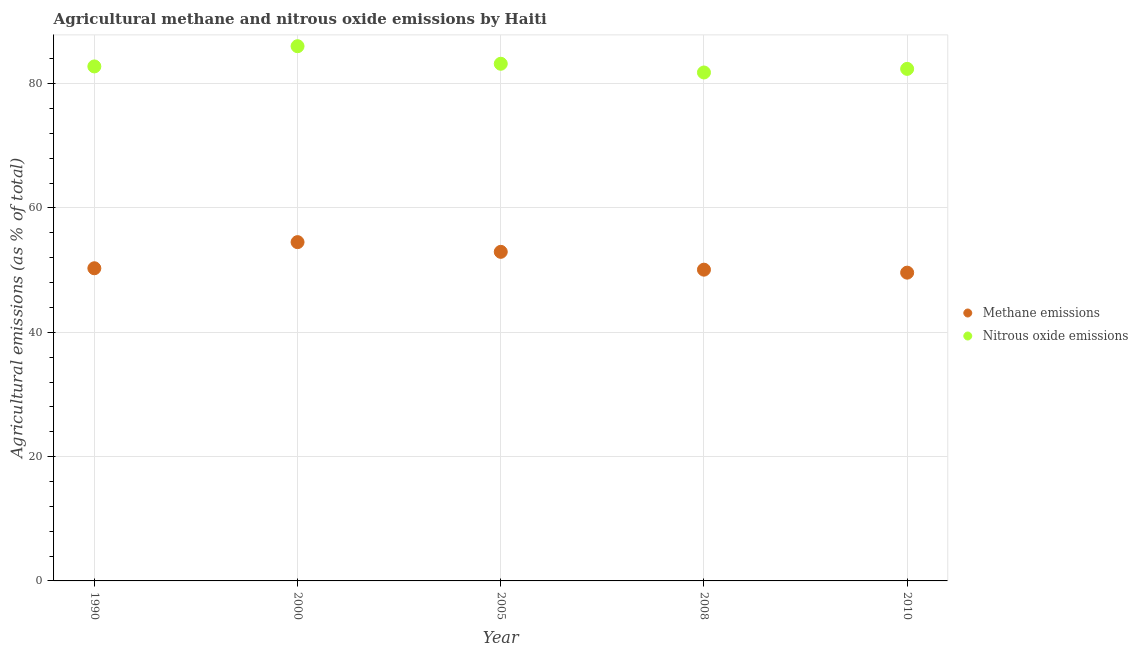How many different coloured dotlines are there?
Provide a short and direct response. 2. What is the amount of nitrous oxide emissions in 2005?
Your answer should be very brief. 83.2. Across all years, what is the maximum amount of methane emissions?
Make the answer very short. 54.51. Across all years, what is the minimum amount of methane emissions?
Ensure brevity in your answer.  49.6. What is the total amount of nitrous oxide emissions in the graph?
Keep it short and to the point. 416.19. What is the difference between the amount of methane emissions in 2000 and that in 2010?
Your response must be concise. 4.91. What is the difference between the amount of methane emissions in 2010 and the amount of nitrous oxide emissions in 2005?
Ensure brevity in your answer.  -33.61. What is the average amount of nitrous oxide emissions per year?
Your answer should be compact. 83.24. In the year 2005, what is the difference between the amount of methane emissions and amount of nitrous oxide emissions?
Provide a short and direct response. -30.26. What is the ratio of the amount of methane emissions in 1990 to that in 2008?
Give a very brief answer. 1. Is the amount of nitrous oxide emissions in 2005 less than that in 2008?
Your answer should be very brief. No. What is the difference between the highest and the second highest amount of nitrous oxide emissions?
Provide a succinct answer. 2.83. What is the difference between the highest and the lowest amount of nitrous oxide emissions?
Your answer should be very brief. 4.23. Is the sum of the amount of methane emissions in 1990 and 2005 greater than the maximum amount of nitrous oxide emissions across all years?
Provide a succinct answer. Yes. Does the amount of methane emissions monotonically increase over the years?
Provide a short and direct response. No. How many years are there in the graph?
Keep it short and to the point. 5. What is the difference between two consecutive major ticks on the Y-axis?
Ensure brevity in your answer.  20. Does the graph contain any zero values?
Provide a short and direct response. No. Where does the legend appear in the graph?
Provide a short and direct response. Center right. How many legend labels are there?
Give a very brief answer. 2. What is the title of the graph?
Keep it short and to the point. Agricultural methane and nitrous oxide emissions by Haiti. Does "Imports" appear as one of the legend labels in the graph?
Keep it short and to the point. No. What is the label or title of the Y-axis?
Offer a terse response. Agricultural emissions (as % of total). What is the Agricultural emissions (as % of total) in Methane emissions in 1990?
Your answer should be compact. 50.3. What is the Agricultural emissions (as % of total) of Nitrous oxide emissions in 1990?
Provide a succinct answer. 82.77. What is the Agricultural emissions (as % of total) of Methane emissions in 2000?
Your answer should be compact. 54.51. What is the Agricultural emissions (as % of total) in Nitrous oxide emissions in 2000?
Keep it short and to the point. 86.03. What is the Agricultural emissions (as % of total) of Methane emissions in 2005?
Ensure brevity in your answer.  52.94. What is the Agricultural emissions (as % of total) in Nitrous oxide emissions in 2005?
Ensure brevity in your answer.  83.2. What is the Agricultural emissions (as % of total) of Methane emissions in 2008?
Your answer should be compact. 50.08. What is the Agricultural emissions (as % of total) in Nitrous oxide emissions in 2008?
Provide a short and direct response. 81.8. What is the Agricultural emissions (as % of total) in Methane emissions in 2010?
Provide a short and direct response. 49.6. What is the Agricultural emissions (as % of total) in Nitrous oxide emissions in 2010?
Keep it short and to the point. 82.38. Across all years, what is the maximum Agricultural emissions (as % of total) of Methane emissions?
Keep it short and to the point. 54.51. Across all years, what is the maximum Agricultural emissions (as % of total) in Nitrous oxide emissions?
Offer a very short reply. 86.03. Across all years, what is the minimum Agricultural emissions (as % of total) in Methane emissions?
Offer a very short reply. 49.6. Across all years, what is the minimum Agricultural emissions (as % of total) of Nitrous oxide emissions?
Provide a succinct answer. 81.8. What is the total Agricultural emissions (as % of total) of Methane emissions in the graph?
Your answer should be compact. 257.43. What is the total Agricultural emissions (as % of total) in Nitrous oxide emissions in the graph?
Offer a very short reply. 416.19. What is the difference between the Agricultural emissions (as % of total) of Methane emissions in 1990 and that in 2000?
Offer a terse response. -4.2. What is the difference between the Agricultural emissions (as % of total) in Nitrous oxide emissions in 1990 and that in 2000?
Keep it short and to the point. -3.25. What is the difference between the Agricultural emissions (as % of total) of Methane emissions in 1990 and that in 2005?
Keep it short and to the point. -2.64. What is the difference between the Agricultural emissions (as % of total) in Nitrous oxide emissions in 1990 and that in 2005?
Your answer should be very brief. -0.43. What is the difference between the Agricultural emissions (as % of total) of Methane emissions in 1990 and that in 2008?
Your answer should be very brief. 0.23. What is the difference between the Agricultural emissions (as % of total) of Nitrous oxide emissions in 1990 and that in 2008?
Provide a succinct answer. 0.97. What is the difference between the Agricultural emissions (as % of total) in Methane emissions in 1990 and that in 2010?
Keep it short and to the point. 0.71. What is the difference between the Agricultural emissions (as % of total) in Nitrous oxide emissions in 1990 and that in 2010?
Your answer should be very brief. 0.39. What is the difference between the Agricultural emissions (as % of total) of Methane emissions in 2000 and that in 2005?
Keep it short and to the point. 1.56. What is the difference between the Agricultural emissions (as % of total) of Nitrous oxide emissions in 2000 and that in 2005?
Ensure brevity in your answer.  2.83. What is the difference between the Agricultural emissions (as % of total) in Methane emissions in 2000 and that in 2008?
Ensure brevity in your answer.  4.43. What is the difference between the Agricultural emissions (as % of total) of Nitrous oxide emissions in 2000 and that in 2008?
Your answer should be very brief. 4.23. What is the difference between the Agricultural emissions (as % of total) of Methane emissions in 2000 and that in 2010?
Provide a short and direct response. 4.91. What is the difference between the Agricultural emissions (as % of total) in Nitrous oxide emissions in 2000 and that in 2010?
Offer a terse response. 3.65. What is the difference between the Agricultural emissions (as % of total) of Methane emissions in 2005 and that in 2008?
Offer a very short reply. 2.87. What is the difference between the Agricultural emissions (as % of total) of Nitrous oxide emissions in 2005 and that in 2008?
Give a very brief answer. 1.4. What is the difference between the Agricultural emissions (as % of total) in Methane emissions in 2005 and that in 2010?
Keep it short and to the point. 3.35. What is the difference between the Agricultural emissions (as % of total) of Nitrous oxide emissions in 2005 and that in 2010?
Offer a terse response. 0.82. What is the difference between the Agricultural emissions (as % of total) in Methane emissions in 2008 and that in 2010?
Your answer should be very brief. 0.48. What is the difference between the Agricultural emissions (as % of total) in Nitrous oxide emissions in 2008 and that in 2010?
Offer a very short reply. -0.58. What is the difference between the Agricultural emissions (as % of total) of Methane emissions in 1990 and the Agricultural emissions (as % of total) of Nitrous oxide emissions in 2000?
Make the answer very short. -35.73. What is the difference between the Agricultural emissions (as % of total) of Methane emissions in 1990 and the Agricultural emissions (as % of total) of Nitrous oxide emissions in 2005?
Your response must be concise. -32.9. What is the difference between the Agricultural emissions (as % of total) of Methane emissions in 1990 and the Agricultural emissions (as % of total) of Nitrous oxide emissions in 2008?
Offer a terse response. -31.5. What is the difference between the Agricultural emissions (as % of total) in Methane emissions in 1990 and the Agricultural emissions (as % of total) in Nitrous oxide emissions in 2010?
Provide a short and direct response. -32.08. What is the difference between the Agricultural emissions (as % of total) of Methane emissions in 2000 and the Agricultural emissions (as % of total) of Nitrous oxide emissions in 2005?
Ensure brevity in your answer.  -28.7. What is the difference between the Agricultural emissions (as % of total) in Methane emissions in 2000 and the Agricultural emissions (as % of total) in Nitrous oxide emissions in 2008?
Make the answer very short. -27.29. What is the difference between the Agricultural emissions (as % of total) of Methane emissions in 2000 and the Agricultural emissions (as % of total) of Nitrous oxide emissions in 2010?
Provide a succinct answer. -27.88. What is the difference between the Agricultural emissions (as % of total) in Methane emissions in 2005 and the Agricultural emissions (as % of total) in Nitrous oxide emissions in 2008?
Keep it short and to the point. -28.86. What is the difference between the Agricultural emissions (as % of total) of Methane emissions in 2005 and the Agricultural emissions (as % of total) of Nitrous oxide emissions in 2010?
Provide a short and direct response. -29.44. What is the difference between the Agricultural emissions (as % of total) in Methane emissions in 2008 and the Agricultural emissions (as % of total) in Nitrous oxide emissions in 2010?
Offer a very short reply. -32.3. What is the average Agricultural emissions (as % of total) in Methane emissions per year?
Make the answer very short. 51.49. What is the average Agricultural emissions (as % of total) of Nitrous oxide emissions per year?
Make the answer very short. 83.24. In the year 1990, what is the difference between the Agricultural emissions (as % of total) of Methane emissions and Agricultural emissions (as % of total) of Nitrous oxide emissions?
Give a very brief answer. -32.47. In the year 2000, what is the difference between the Agricultural emissions (as % of total) of Methane emissions and Agricultural emissions (as % of total) of Nitrous oxide emissions?
Give a very brief answer. -31.52. In the year 2005, what is the difference between the Agricultural emissions (as % of total) in Methane emissions and Agricultural emissions (as % of total) in Nitrous oxide emissions?
Your answer should be compact. -30.26. In the year 2008, what is the difference between the Agricultural emissions (as % of total) in Methane emissions and Agricultural emissions (as % of total) in Nitrous oxide emissions?
Offer a very short reply. -31.72. In the year 2010, what is the difference between the Agricultural emissions (as % of total) of Methane emissions and Agricultural emissions (as % of total) of Nitrous oxide emissions?
Provide a succinct answer. -32.78. What is the ratio of the Agricultural emissions (as % of total) of Methane emissions in 1990 to that in 2000?
Your answer should be very brief. 0.92. What is the ratio of the Agricultural emissions (as % of total) in Nitrous oxide emissions in 1990 to that in 2000?
Make the answer very short. 0.96. What is the ratio of the Agricultural emissions (as % of total) of Methane emissions in 1990 to that in 2005?
Your response must be concise. 0.95. What is the ratio of the Agricultural emissions (as % of total) of Methane emissions in 1990 to that in 2008?
Offer a very short reply. 1. What is the ratio of the Agricultural emissions (as % of total) in Nitrous oxide emissions in 1990 to that in 2008?
Your answer should be very brief. 1.01. What is the ratio of the Agricultural emissions (as % of total) in Methane emissions in 1990 to that in 2010?
Your answer should be very brief. 1.01. What is the ratio of the Agricultural emissions (as % of total) of Methane emissions in 2000 to that in 2005?
Offer a terse response. 1.03. What is the ratio of the Agricultural emissions (as % of total) of Nitrous oxide emissions in 2000 to that in 2005?
Provide a short and direct response. 1.03. What is the ratio of the Agricultural emissions (as % of total) of Methane emissions in 2000 to that in 2008?
Your answer should be very brief. 1.09. What is the ratio of the Agricultural emissions (as % of total) of Nitrous oxide emissions in 2000 to that in 2008?
Your response must be concise. 1.05. What is the ratio of the Agricultural emissions (as % of total) in Methane emissions in 2000 to that in 2010?
Keep it short and to the point. 1.1. What is the ratio of the Agricultural emissions (as % of total) of Nitrous oxide emissions in 2000 to that in 2010?
Your answer should be compact. 1.04. What is the ratio of the Agricultural emissions (as % of total) in Methane emissions in 2005 to that in 2008?
Give a very brief answer. 1.06. What is the ratio of the Agricultural emissions (as % of total) of Nitrous oxide emissions in 2005 to that in 2008?
Offer a terse response. 1.02. What is the ratio of the Agricultural emissions (as % of total) of Methane emissions in 2005 to that in 2010?
Give a very brief answer. 1.07. What is the ratio of the Agricultural emissions (as % of total) in Methane emissions in 2008 to that in 2010?
Offer a very short reply. 1.01. What is the ratio of the Agricultural emissions (as % of total) of Nitrous oxide emissions in 2008 to that in 2010?
Your response must be concise. 0.99. What is the difference between the highest and the second highest Agricultural emissions (as % of total) of Methane emissions?
Keep it short and to the point. 1.56. What is the difference between the highest and the second highest Agricultural emissions (as % of total) of Nitrous oxide emissions?
Your response must be concise. 2.83. What is the difference between the highest and the lowest Agricultural emissions (as % of total) of Methane emissions?
Ensure brevity in your answer.  4.91. What is the difference between the highest and the lowest Agricultural emissions (as % of total) in Nitrous oxide emissions?
Your answer should be compact. 4.23. 